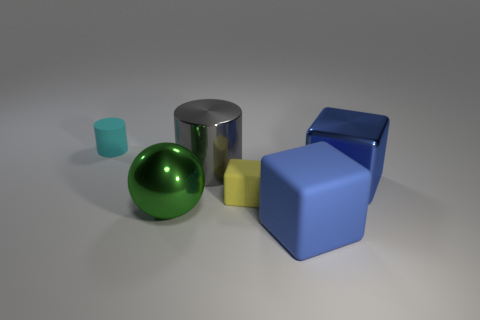Subtract all small rubber cubes. How many cubes are left? 2 Subtract all green balls. How many blue blocks are left? 2 Add 4 gray cylinders. How many objects exist? 10 Subtract all balls. How many objects are left? 5 Subtract 1 blocks. How many blocks are left? 2 Subtract 0 cyan cubes. How many objects are left? 6 Subtract all brown cubes. Subtract all purple cylinders. How many cubes are left? 3 Subtract all large cylinders. Subtract all small matte cubes. How many objects are left? 4 Add 5 cyan things. How many cyan things are left? 6 Add 4 large gray cylinders. How many large gray cylinders exist? 5 